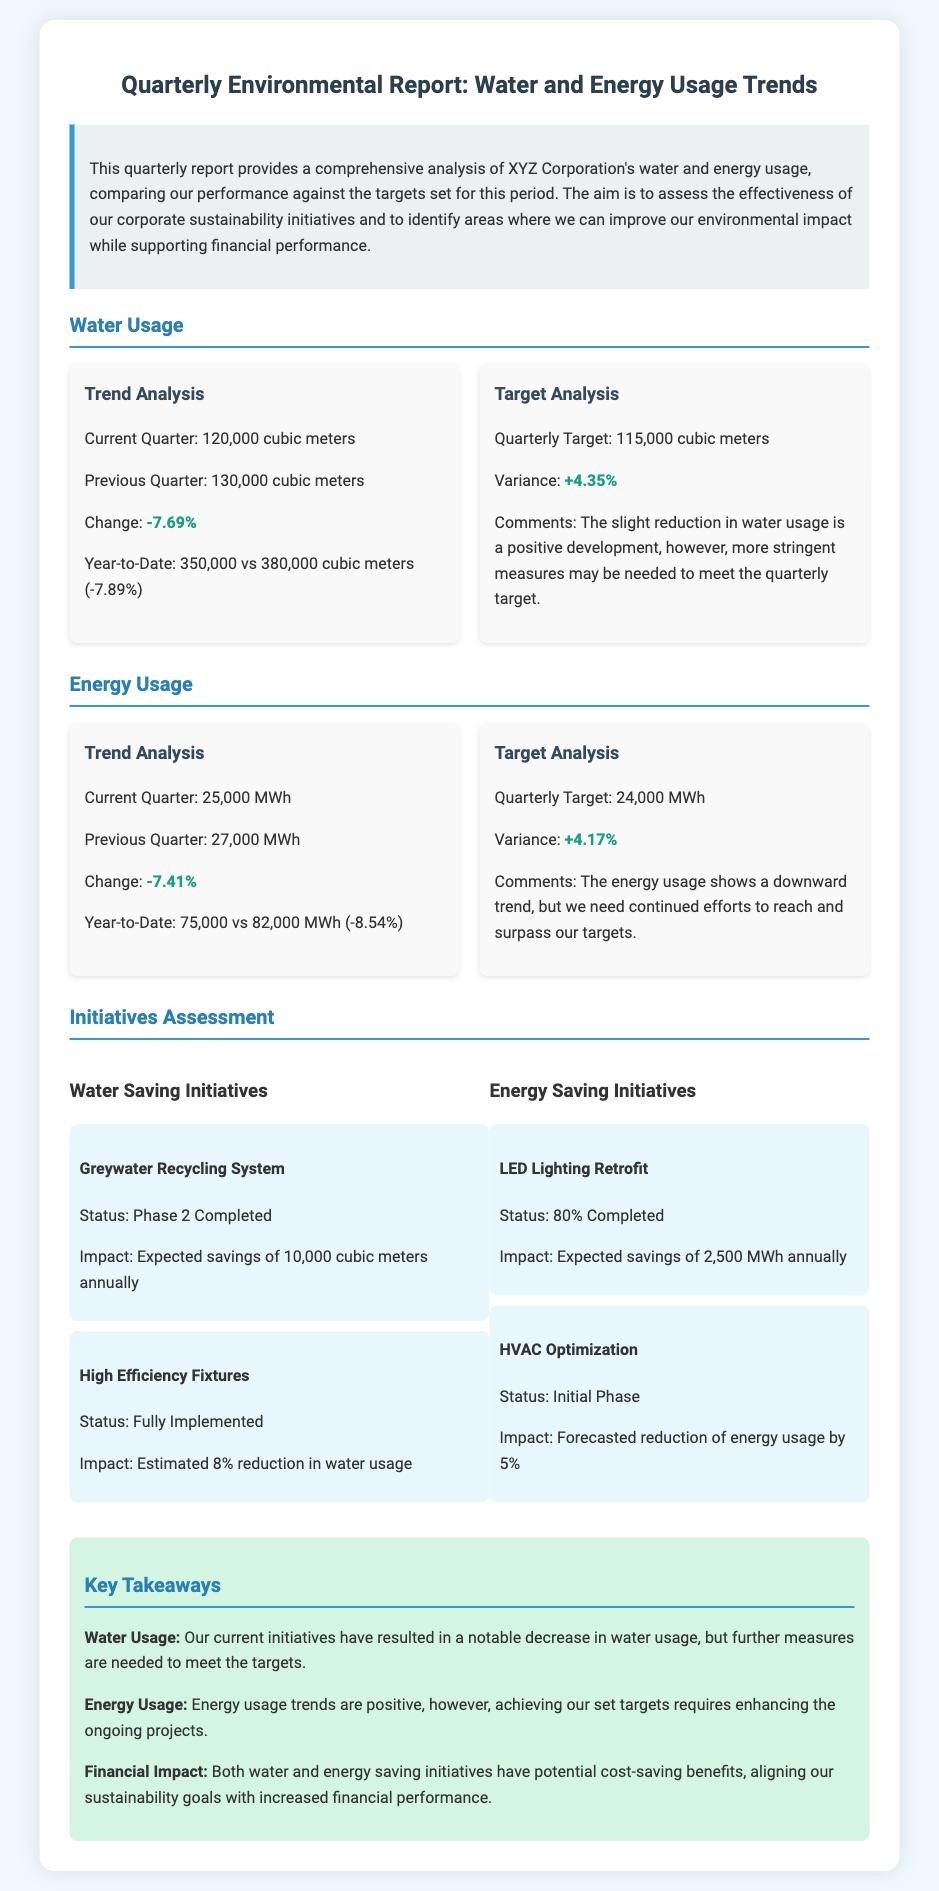What was the water usage in the current quarter? The document states that the current quarter's water usage is 120,000 cubic meters.
Answer: 120,000 cubic meters What was the previous quarter's energy usage? According to the document, the previous quarter’s energy usage was 27,000 MWh.
Answer: 27,000 MWh What is the quarterly target for water usage? The document indicates that the quarterly target for water usage is 115,000 cubic meters.
Answer: 115,000 cubic meters What is the highlighted change in water usage percentage? The highlighted change in water usage percentage is -7.69%.
Answer: -7.69% What impact is expected from the greywater recycling system? The document mentions that the expected savings from the greywater recycling system is 10,000 cubic meters annually.
Answer: 10,000 cubic meters annually Explain the significance of the variance in energy usage target. The variance in energy usage target signifies how current performance compares with set goals. Here, the variance is +4.17%, meaning energy usage exceeded the target.
Answer: +4.17% How many initiatives are currently reported under water saving initiatives? There are two initiatives reported under water-saving initiatives.
Answer: Two initiatives What is the status of the HVAC optimization initiative? The document states that the HVAC optimization initiative is in the initial phase.
Answer: Initial phase What are the two key areas covered in this report? The report covers water usage and energy usage trends.
Answer: Water and energy usage trends 